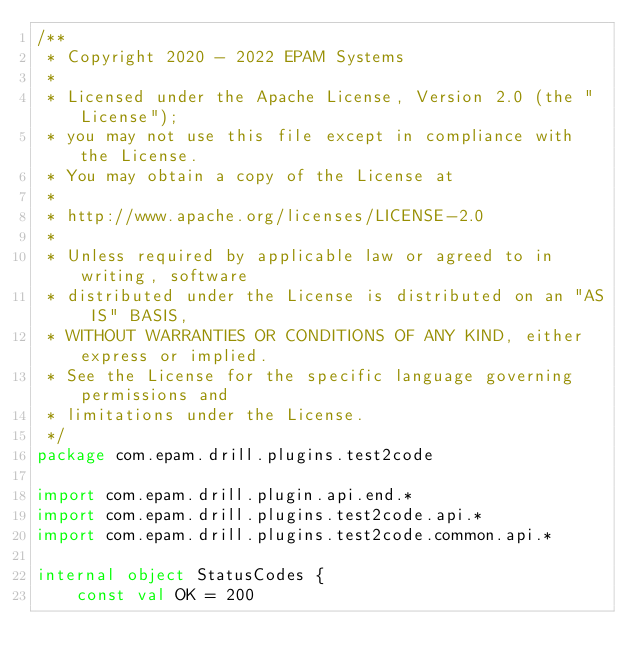<code> <loc_0><loc_0><loc_500><loc_500><_Kotlin_>/**
 * Copyright 2020 - 2022 EPAM Systems
 *
 * Licensed under the Apache License, Version 2.0 (the "License");
 * you may not use this file except in compliance with the License.
 * You may obtain a copy of the License at
 *
 * http://www.apache.org/licenses/LICENSE-2.0
 *
 * Unless required by applicable law or agreed to in writing, software
 * distributed under the License is distributed on an "AS IS" BASIS,
 * WITHOUT WARRANTIES OR CONDITIONS OF ANY KIND, either express or implied.
 * See the License for the specific language governing permissions and
 * limitations under the License.
 */
package com.epam.drill.plugins.test2code

import com.epam.drill.plugin.api.end.*
import com.epam.drill.plugins.test2code.api.*
import com.epam.drill.plugins.test2code.common.api.*

internal object StatusCodes {
    const val OK = 200</code> 